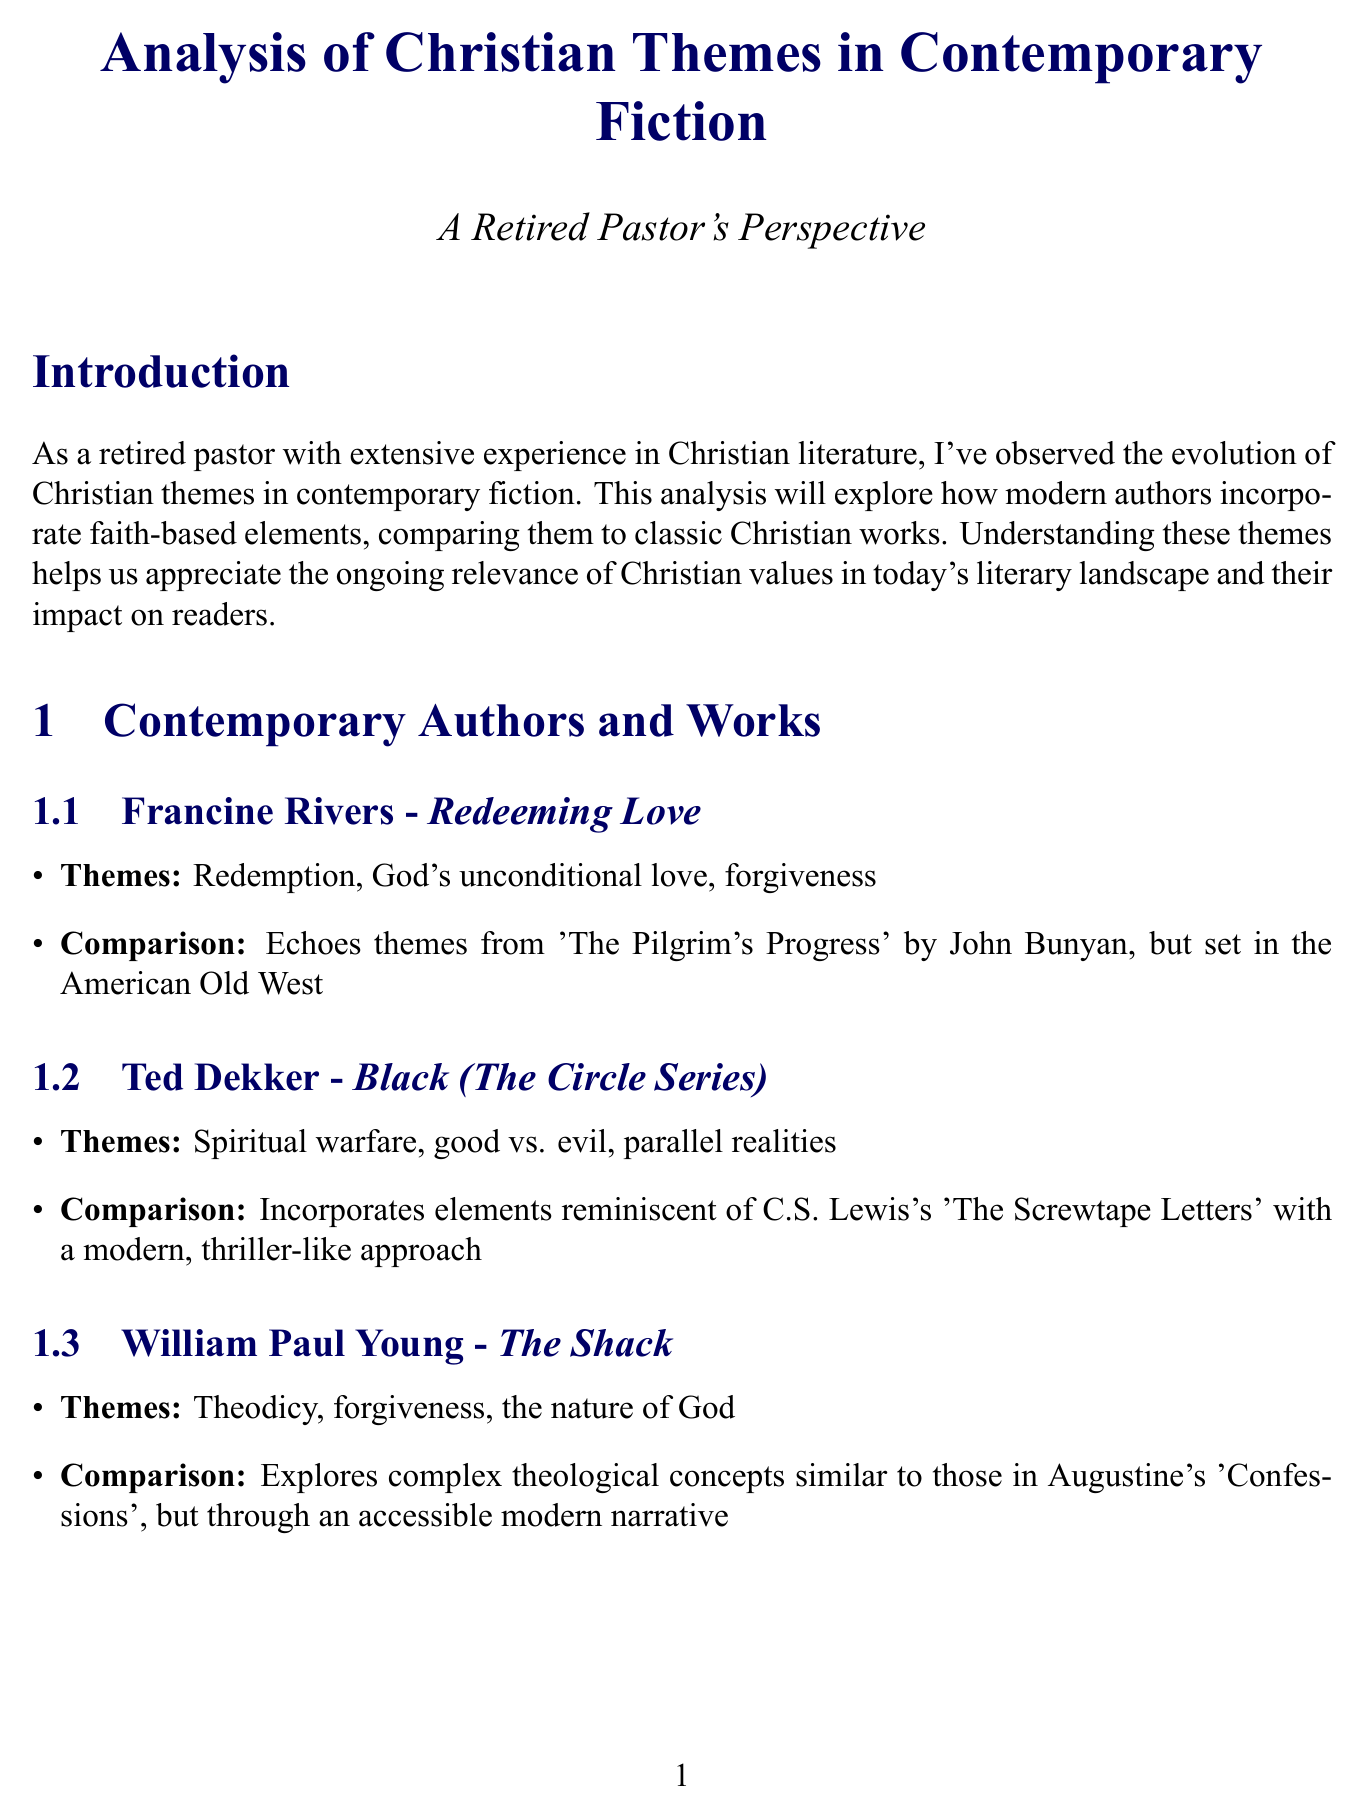What is the notable work of Francine Rivers? The notable work of Francine Rivers is listed in the document as “Redeeming Love.”
Answer: Redeeming Love Which theme is associated with Ted Dekker's work? The themes in Ted Dekker’s work “Black (The Circle Series)” include spiritual warfare, good vs. evil, and parallel realities.
Answer: Spiritual warfare, good vs. evil, parallel realities What is a recurring theme mentioned in the document? The document lists several recurring themes, which include redemption, faith vs. doubt, and divine providence.
Answer: Redemption Which literary technique uses symbolic figures and actions? The document describes allegory as a literary technique that uses symbolic figures and actions to convey spiritual truths.
Answer: Allegory Who is the author of “The Shack”? The author of “The Shack” is William Paul Young, as stated in the document.
Answer: William Paul Young What issue is raised regarding theological accuracy? The document mentions that some works prioritize storytelling over doctrinal precision as an issue regarding theological accuracy.
Answer: Prioritize storytelling over doctrinal precision What is one impact of contemporary Christian fiction on readers? The document states that contemporary Christian fiction often serves as a tool for readers to explore and deepen their faith.
Answer: Explore and deepen their faith Which classic work does "The Shack" relate to in terms of themes? The comparison made in the document notes that "The Shack" explores complex theological concepts similar to those in Augustine's “Confessions.”
Answer: Augustine's Confessions 